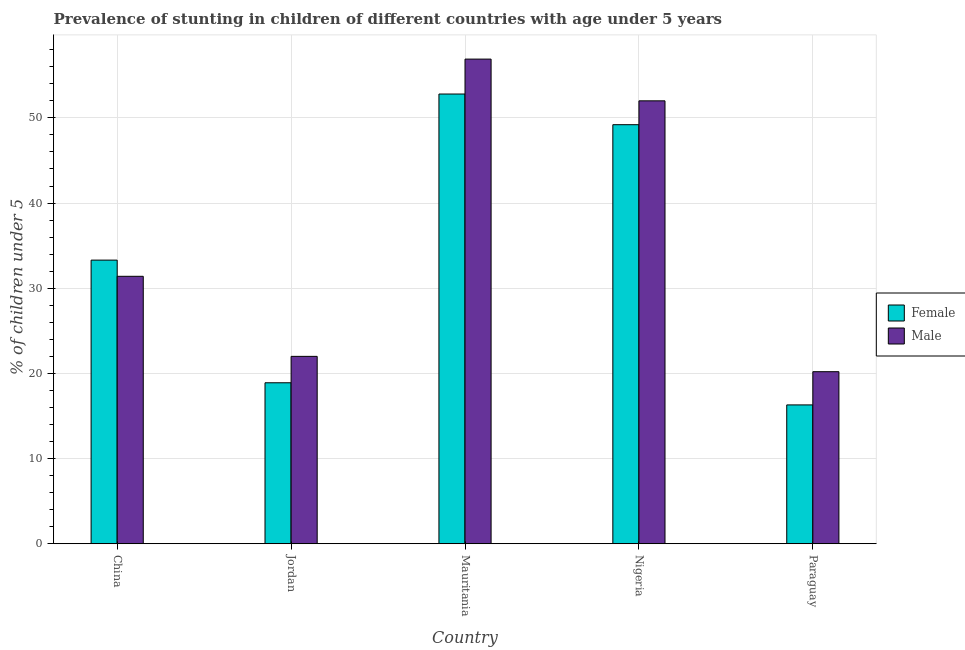How many groups of bars are there?
Your answer should be very brief. 5. How many bars are there on the 4th tick from the right?
Provide a succinct answer. 2. What is the label of the 3rd group of bars from the left?
Your response must be concise. Mauritania. What is the percentage of stunted male children in Mauritania?
Give a very brief answer. 56.9. Across all countries, what is the maximum percentage of stunted female children?
Ensure brevity in your answer.  52.8. Across all countries, what is the minimum percentage of stunted female children?
Make the answer very short. 16.3. In which country was the percentage of stunted male children maximum?
Provide a succinct answer. Mauritania. In which country was the percentage of stunted female children minimum?
Make the answer very short. Paraguay. What is the total percentage of stunted female children in the graph?
Keep it short and to the point. 170.5. What is the difference between the percentage of stunted male children in Jordan and that in Paraguay?
Your answer should be very brief. 1.8. What is the difference between the percentage of stunted female children in China and the percentage of stunted male children in Mauritania?
Your answer should be compact. -23.6. What is the average percentage of stunted female children per country?
Your answer should be very brief. 34.1. What is the difference between the percentage of stunted male children and percentage of stunted female children in Nigeria?
Your response must be concise. 2.8. What is the ratio of the percentage of stunted male children in Mauritania to that in Nigeria?
Give a very brief answer. 1.09. Is the percentage of stunted male children in Jordan less than that in Paraguay?
Keep it short and to the point. No. What is the difference between the highest and the second highest percentage of stunted female children?
Provide a short and direct response. 3.6. What is the difference between the highest and the lowest percentage of stunted female children?
Your answer should be compact. 36.5. In how many countries, is the percentage of stunted female children greater than the average percentage of stunted female children taken over all countries?
Your response must be concise. 2. Is the sum of the percentage of stunted male children in China and Mauritania greater than the maximum percentage of stunted female children across all countries?
Provide a succinct answer. Yes. How many bars are there?
Your answer should be compact. 10. What is the difference between two consecutive major ticks on the Y-axis?
Make the answer very short. 10. Are the values on the major ticks of Y-axis written in scientific E-notation?
Provide a short and direct response. No. Does the graph contain grids?
Offer a terse response. Yes. Where does the legend appear in the graph?
Provide a short and direct response. Center right. How many legend labels are there?
Your response must be concise. 2. What is the title of the graph?
Ensure brevity in your answer.  Prevalence of stunting in children of different countries with age under 5 years. What is the label or title of the Y-axis?
Your response must be concise.  % of children under 5. What is the  % of children under 5 in Female in China?
Offer a very short reply. 33.3. What is the  % of children under 5 in Male in China?
Your answer should be compact. 31.4. What is the  % of children under 5 of Female in Jordan?
Provide a succinct answer. 18.9. What is the  % of children under 5 in Male in Jordan?
Offer a very short reply. 22. What is the  % of children under 5 of Female in Mauritania?
Offer a terse response. 52.8. What is the  % of children under 5 of Male in Mauritania?
Your answer should be very brief. 56.9. What is the  % of children under 5 of Female in Nigeria?
Provide a succinct answer. 49.2. What is the  % of children under 5 of Male in Nigeria?
Your answer should be very brief. 52. What is the  % of children under 5 of Female in Paraguay?
Ensure brevity in your answer.  16.3. What is the  % of children under 5 in Male in Paraguay?
Offer a very short reply. 20.2. Across all countries, what is the maximum  % of children under 5 of Female?
Your answer should be compact. 52.8. Across all countries, what is the maximum  % of children under 5 of Male?
Ensure brevity in your answer.  56.9. Across all countries, what is the minimum  % of children under 5 of Female?
Your answer should be compact. 16.3. Across all countries, what is the minimum  % of children under 5 in Male?
Provide a short and direct response. 20.2. What is the total  % of children under 5 in Female in the graph?
Keep it short and to the point. 170.5. What is the total  % of children under 5 of Male in the graph?
Your response must be concise. 182.5. What is the difference between the  % of children under 5 in Female in China and that in Mauritania?
Offer a very short reply. -19.5. What is the difference between the  % of children under 5 of Male in China and that in Mauritania?
Your answer should be compact. -25.5. What is the difference between the  % of children under 5 in Female in China and that in Nigeria?
Keep it short and to the point. -15.9. What is the difference between the  % of children under 5 of Male in China and that in Nigeria?
Provide a short and direct response. -20.6. What is the difference between the  % of children under 5 of Female in China and that in Paraguay?
Provide a short and direct response. 17. What is the difference between the  % of children under 5 of Female in Jordan and that in Mauritania?
Offer a very short reply. -33.9. What is the difference between the  % of children under 5 of Male in Jordan and that in Mauritania?
Your answer should be compact. -34.9. What is the difference between the  % of children under 5 of Female in Jordan and that in Nigeria?
Give a very brief answer. -30.3. What is the difference between the  % of children under 5 of Male in Jordan and that in Nigeria?
Provide a succinct answer. -30. What is the difference between the  % of children under 5 in Female in Jordan and that in Paraguay?
Give a very brief answer. 2.6. What is the difference between the  % of children under 5 in Female in Mauritania and that in Nigeria?
Your answer should be compact. 3.6. What is the difference between the  % of children under 5 of Female in Mauritania and that in Paraguay?
Provide a short and direct response. 36.5. What is the difference between the  % of children under 5 of Male in Mauritania and that in Paraguay?
Provide a succinct answer. 36.7. What is the difference between the  % of children under 5 in Female in Nigeria and that in Paraguay?
Keep it short and to the point. 32.9. What is the difference between the  % of children under 5 of Male in Nigeria and that in Paraguay?
Your answer should be very brief. 31.8. What is the difference between the  % of children under 5 of Female in China and the  % of children under 5 of Male in Jordan?
Give a very brief answer. 11.3. What is the difference between the  % of children under 5 of Female in China and the  % of children under 5 of Male in Mauritania?
Your answer should be very brief. -23.6. What is the difference between the  % of children under 5 in Female in China and the  % of children under 5 in Male in Nigeria?
Provide a succinct answer. -18.7. What is the difference between the  % of children under 5 in Female in China and the  % of children under 5 in Male in Paraguay?
Make the answer very short. 13.1. What is the difference between the  % of children under 5 of Female in Jordan and the  % of children under 5 of Male in Mauritania?
Give a very brief answer. -38. What is the difference between the  % of children under 5 in Female in Jordan and the  % of children under 5 in Male in Nigeria?
Ensure brevity in your answer.  -33.1. What is the difference between the  % of children under 5 of Female in Jordan and the  % of children under 5 of Male in Paraguay?
Offer a very short reply. -1.3. What is the difference between the  % of children under 5 in Female in Mauritania and the  % of children under 5 in Male in Paraguay?
Your answer should be very brief. 32.6. What is the average  % of children under 5 in Female per country?
Ensure brevity in your answer.  34.1. What is the average  % of children under 5 of Male per country?
Your response must be concise. 36.5. What is the difference between the  % of children under 5 in Female and  % of children under 5 in Male in China?
Keep it short and to the point. 1.9. What is the difference between the  % of children under 5 of Female and  % of children under 5 of Male in Jordan?
Make the answer very short. -3.1. What is the difference between the  % of children under 5 of Female and  % of children under 5 of Male in Mauritania?
Provide a succinct answer. -4.1. What is the difference between the  % of children under 5 of Female and  % of children under 5 of Male in Nigeria?
Your answer should be very brief. -2.8. What is the ratio of the  % of children under 5 in Female in China to that in Jordan?
Your answer should be compact. 1.76. What is the ratio of the  % of children under 5 of Male in China to that in Jordan?
Offer a terse response. 1.43. What is the ratio of the  % of children under 5 in Female in China to that in Mauritania?
Your answer should be compact. 0.63. What is the ratio of the  % of children under 5 of Male in China to that in Mauritania?
Keep it short and to the point. 0.55. What is the ratio of the  % of children under 5 in Female in China to that in Nigeria?
Keep it short and to the point. 0.68. What is the ratio of the  % of children under 5 in Male in China to that in Nigeria?
Your answer should be very brief. 0.6. What is the ratio of the  % of children under 5 of Female in China to that in Paraguay?
Your response must be concise. 2.04. What is the ratio of the  % of children under 5 of Male in China to that in Paraguay?
Your answer should be very brief. 1.55. What is the ratio of the  % of children under 5 of Female in Jordan to that in Mauritania?
Provide a succinct answer. 0.36. What is the ratio of the  % of children under 5 of Male in Jordan to that in Mauritania?
Your answer should be very brief. 0.39. What is the ratio of the  % of children under 5 in Female in Jordan to that in Nigeria?
Your answer should be very brief. 0.38. What is the ratio of the  % of children under 5 of Male in Jordan to that in Nigeria?
Offer a very short reply. 0.42. What is the ratio of the  % of children under 5 of Female in Jordan to that in Paraguay?
Keep it short and to the point. 1.16. What is the ratio of the  % of children under 5 of Male in Jordan to that in Paraguay?
Your response must be concise. 1.09. What is the ratio of the  % of children under 5 in Female in Mauritania to that in Nigeria?
Provide a short and direct response. 1.07. What is the ratio of the  % of children under 5 in Male in Mauritania to that in Nigeria?
Make the answer very short. 1.09. What is the ratio of the  % of children under 5 of Female in Mauritania to that in Paraguay?
Ensure brevity in your answer.  3.24. What is the ratio of the  % of children under 5 in Male in Mauritania to that in Paraguay?
Your answer should be compact. 2.82. What is the ratio of the  % of children under 5 of Female in Nigeria to that in Paraguay?
Your answer should be compact. 3.02. What is the ratio of the  % of children under 5 of Male in Nigeria to that in Paraguay?
Your answer should be very brief. 2.57. What is the difference between the highest and the second highest  % of children under 5 of Male?
Give a very brief answer. 4.9. What is the difference between the highest and the lowest  % of children under 5 in Female?
Your answer should be very brief. 36.5. What is the difference between the highest and the lowest  % of children under 5 of Male?
Provide a short and direct response. 36.7. 